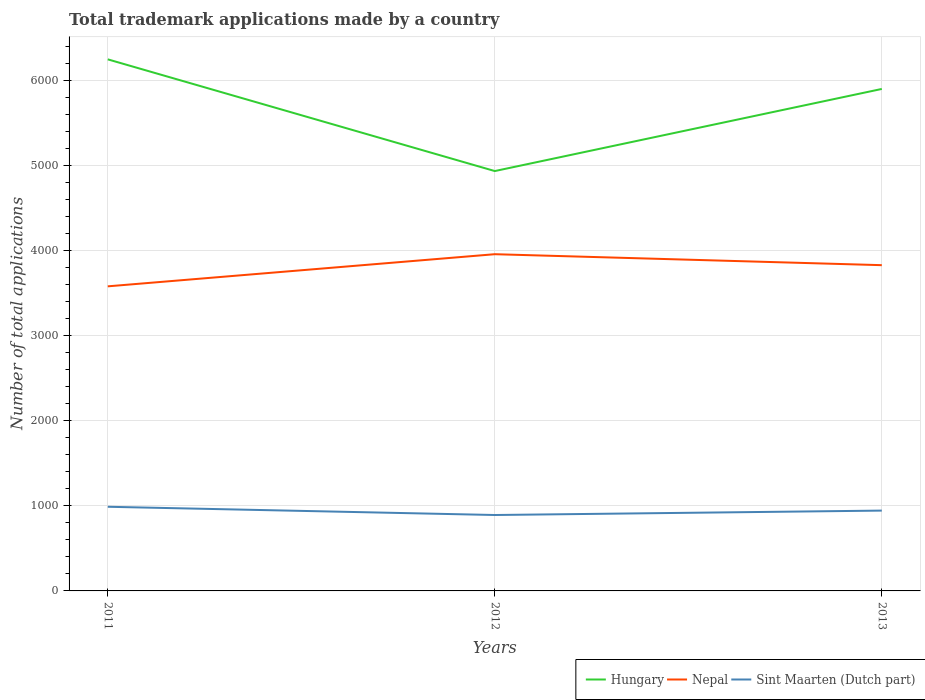Does the line corresponding to Nepal intersect with the line corresponding to Sint Maarten (Dutch part)?
Your response must be concise. No. Is the number of lines equal to the number of legend labels?
Provide a succinct answer. Yes. Across all years, what is the maximum number of applications made by in Sint Maarten (Dutch part)?
Give a very brief answer. 893. In which year was the number of applications made by in Sint Maarten (Dutch part) maximum?
Keep it short and to the point. 2012. What is the total number of applications made by in Sint Maarten (Dutch part) in the graph?
Provide a short and direct response. 97. What is the difference between the highest and the second highest number of applications made by in Hungary?
Give a very brief answer. 1314. What is the difference between the highest and the lowest number of applications made by in Nepal?
Provide a short and direct response. 2. Is the number of applications made by in Nepal strictly greater than the number of applications made by in Hungary over the years?
Give a very brief answer. Yes. How many lines are there?
Your answer should be very brief. 3. How many years are there in the graph?
Ensure brevity in your answer.  3. What is the difference between two consecutive major ticks on the Y-axis?
Your response must be concise. 1000. Does the graph contain grids?
Offer a terse response. Yes. What is the title of the graph?
Your answer should be compact. Total trademark applications made by a country. What is the label or title of the X-axis?
Your answer should be compact. Years. What is the label or title of the Y-axis?
Your answer should be compact. Number of total applications. What is the Number of total applications in Hungary in 2011?
Offer a very short reply. 6253. What is the Number of total applications in Nepal in 2011?
Your answer should be very brief. 3583. What is the Number of total applications of Sint Maarten (Dutch part) in 2011?
Make the answer very short. 990. What is the Number of total applications in Hungary in 2012?
Your answer should be very brief. 4939. What is the Number of total applications in Nepal in 2012?
Your answer should be very brief. 3961. What is the Number of total applications of Sint Maarten (Dutch part) in 2012?
Give a very brief answer. 893. What is the Number of total applications in Hungary in 2013?
Provide a succinct answer. 5905. What is the Number of total applications in Nepal in 2013?
Offer a very short reply. 3832. What is the Number of total applications in Sint Maarten (Dutch part) in 2013?
Keep it short and to the point. 945. Across all years, what is the maximum Number of total applications in Hungary?
Your answer should be compact. 6253. Across all years, what is the maximum Number of total applications of Nepal?
Your answer should be very brief. 3961. Across all years, what is the maximum Number of total applications in Sint Maarten (Dutch part)?
Offer a terse response. 990. Across all years, what is the minimum Number of total applications of Hungary?
Keep it short and to the point. 4939. Across all years, what is the minimum Number of total applications in Nepal?
Offer a terse response. 3583. Across all years, what is the minimum Number of total applications in Sint Maarten (Dutch part)?
Provide a succinct answer. 893. What is the total Number of total applications of Hungary in the graph?
Offer a very short reply. 1.71e+04. What is the total Number of total applications in Nepal in the graph?
Ensure brevity in your answer.  1.14e+04. What is the total Number of total applications of Sint Maarten (Dutch part) in the graph?
Offer a very short reply. 2828. What is the difference between the Number of total applications of Hungary in 2011 and that in 2012?
Offer a terse response. 1314. What is the difference between the Number of total applications of Nepal in 2011 and that in 2012?
Give a very brief answer. -378. What is the difference between the Number of total applications of Sint Maarten (Dutch part) in 2011 and that in 2012?
Your answer should be compact. 97. What is the difference between the Number of total applications of Hungary in 2011 and that in 2013?
Your answer should be compact. 348. What is the difference between the Number of total applications in Nepal in 2011 and that in 2013?
Make the answer very short. -249. What is the difference between the Number of total applications in Sint Maarten (Dutch part) in 2011 and that in 2013?
Your answer should be very brief. 45. What is the difference between the Number of total applications of Hungary in 2012 and that in 2013?
Provide a succinct answer. -966. What is the difference between the Number of total applications in Nepal in 2012 and that in 2013?
Ensure brevity in your answer.  129. What is the difference between the Number of total applications of Sint Maarten (Dutch part) in 2012 and that in 2013?
Offer a terse response. -52. What is the difference between the Number of total applications in Hungary in 2011 and the Number of total applications in Nepal in 2012?
Your answer should be compact. 2292. What is the difference between the Number of total applications in Hungary in 2011 and the Number of total applications in Sint Maarten (Dutch part) in 2012?
Provide a succinct answer. 5360. What is the difference between the Number of total applications of Nepal in 2011 and the Number of total applications of Sint Maarten (Dutch part) in 2012?
Offer a very short reply. 2690. What is the difference between the Number of total applications of Hungary in 2011 and the Number of total applications of Nepal in 2013?
Your answer should be very brief. 2421. What is the difference between the Number of total applications in Hungary in 2011 and the Number of total applications in Sint Maarten (Dutch part) in 2013?
Keep it short and to the point. 5308. What is the difference between the Number of total applications of Nepal in 2011 and the Number of total applications of Sint Maarten (Dutch part) in 2013?
Your answer should be compact. 2638. What is the difference between the Number of total applications of Hungary in 2012 and the Number of total applications of Nepal in 2013?
Keep it short and to the point. 1107. What is the difference between the Number of total applications of Hungary in 2012 and the Number of total applications of Sint Maarten (Dutch part) in 2013?
Provide a succinct answer. 3994. What is the difference between the Number of total applications in Nepal in 2012 and the Number of total applications in Sint Maarten (Dutch part) in 2013?
Your response must be concise. 3016. What is the average Number of total applications in Hungary per year?
Ensure brevity in your answer.  5699. What is the average Number of total applications in Nepal per year?
Your response must be concise. 3792. What is the average Number of total applications of Sint Maarten (Dutch part) per year?
Ensure brevity in your answer.  942.67. In the year 2011, what is the difference between the Number of total applications of Hungary and Number of total applications of Nepal?
Provide a succinct answer. 2670. In the year 2011, what is the difference between the Number of total applications of Hungary and Number of total applications of Sint Maarten (Dutch part)?
Your answer should be compact. 5263. In the year 2011, what is the difference between the Number of total applications in Nepal and Number of total applications in Sint Maarten (Dutch part)?
Give a very brief answer. 2593. In the year 2012, what is the difference between the Number of total applications in Hungary and Number of total applications in Nepal?
Your response must be concise. 978. In the year 2012, what is the difference between the Number of total applications of Hungary and Number of total applications of Sint Maarten (Dutch part)?
Keep it short and to the point. 4046. In the year 2012, what is the difference between the Number of total applications in Nepal and Number of total applications in Sint Maarten (Dutch part)?
Offer a very short reply. 3068. In the year 2013, what is the difference between the Number of total applications in Hungary and Number of total applications in Nepal?
Provide a short and direct response. 2073. In the year 2013, what is the difference between the Number of total applications of Hungary and Number of total applications of Sint Maarten (Dutch part)?
Provide a succinct answer. 4960. In the year 2013, what is the difference between the Number of total applications in Nepal and Number of total applications in Sint Maarten (Dutch part)?
Your answer should be compact. 2887. What is the ratio of the Number of total applications of Hungary in 2011 to that in 2012?
Provide a short and direct response. 1.27. What is the ratio of the Number of total applications in Nepal in 2011 to that in 2012?
Provide a short and direct response. 0.9. What is the ratio of the Number of total applications in Sint Maarten (Dutch part) in 2011 to that in 2012?
Offer a terse response. 1.11. What is the ratio of the Number of total applications of Hungary in 2011 to that in 2013?
Keep it short and to the point. 1.06. What is the ratio of the Number of total applications in Nepal in 2011 to that in 2013?
Provide a succinct answer. 0.94. What is the ratio of the Number of total applications in Sint Maarten (Dutch part) in 2011 to that in 2013?
Give a very brief answer. 1.05. What is the ratio of the Number of total applications in Hungary in 2012 to that in 2013?
Make the answer very short. 0.84. What is the ratio of the Number of total applications of Nepal in 2012 to that in 2013?
Ensure brevity in your answer.  1.03. What is the ratio of the Number of total applications of Sint Maarten (Dutch part) in 2012 to that in 2013?
Provide a short and direct response. 0.94. What is the difference between the highest and the second highest Number of total applications of Hungary?
Ensure brevity in your answer.  348. What is the difference between the highest and the second highest Number of total applications in Nepal?
Keep it short and to the point. 129. What is the difference between the highest and the second highest Number of total applications of Sint Maarten (Dutch part)?
Give a very brief answer. 45. What is the difference between the highest and the lowest Number of total applications of Hungary?
Your answer should be compact. 1314. What is the difference between the highest and the lowest Number of total applications of Nepal?
Make the answer very short. 378. What is the difference between the highest and the lowest Number of total applications of Sint Maarten (Dutch part)?
Ensure brevity in your answer.  97. 